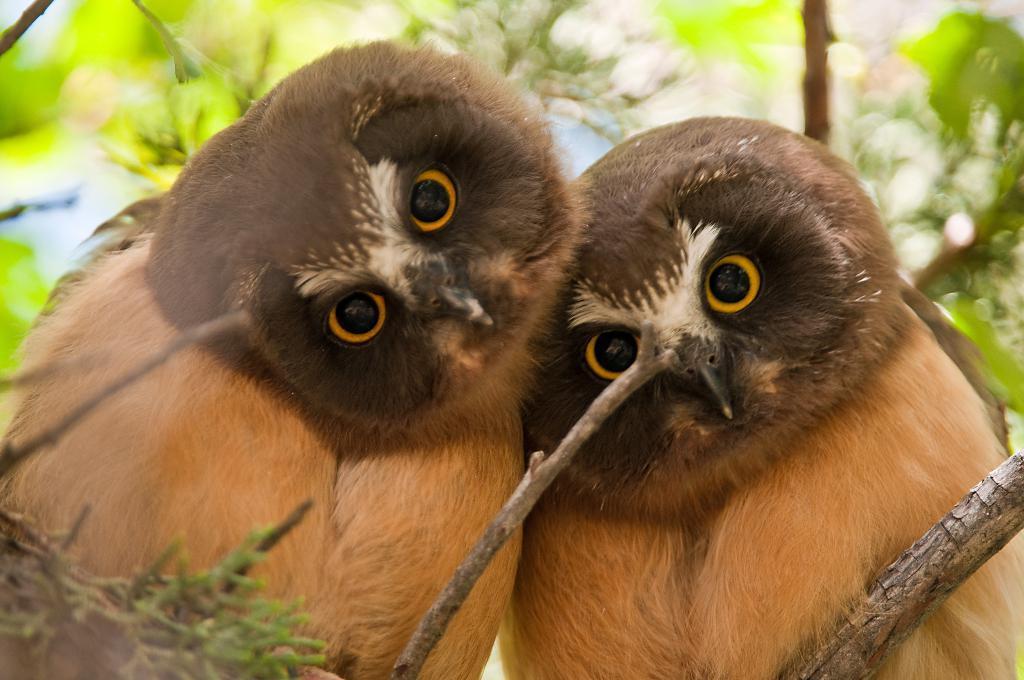In one or two sentences, can you explain what this image depicts? In this image there are two owls sitting on a branch of a tree. In front of them there are stems. In the background there are leaves of a tree. 